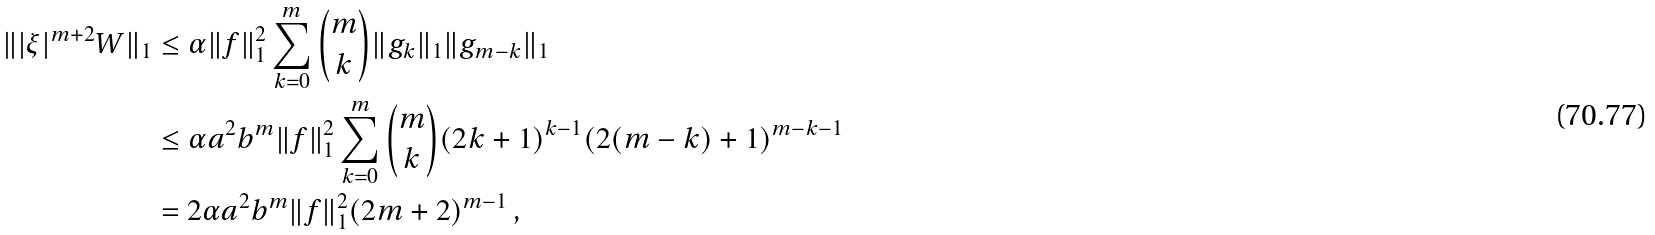Convert formula to latex. <formula><loc_0><loc_0><loc_500><loc_500>\| | \xi | ^ { m + 2 } W \| _ { 1 } & \leq \alpha \| f \| _ { 1 } ^ { 2 } \sum _ { k = 0 } ^ { m } \binom { m } { k } \| g _ { k } \| _ { 1 } \| g _ { m - k } \| _ { 1 } \\ & \leq \alpha a ^ { 2 } b ^ { m } \| f \| _ { 1 } ^ { 2 } \sum _ { k = 0 } ^ { m } \binom { m } { k } ( 2 k + 1 ) ^ { k - 1 } ( 2 ( m - k ) + 1 ) ^ { m - k - 1 } \\ & = 2 \alpha a ^ { 2 } b ^ { m } \| f \| _ { 1 } ^ { 2 } ( 2 m + 2 ) ^ { m - 1 } \, ,</formula> 